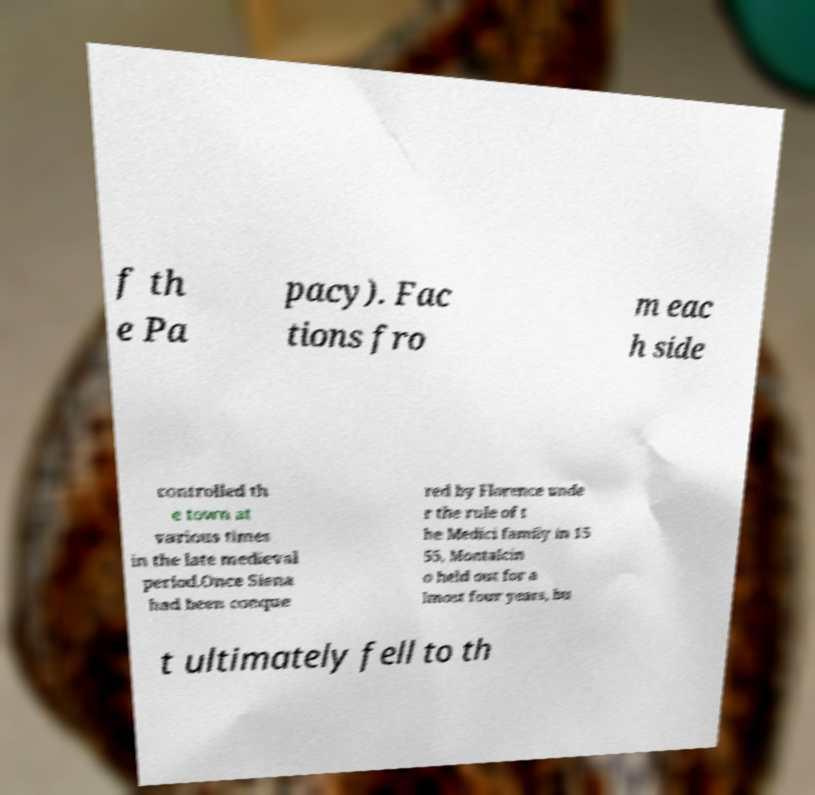Could you assist in decoding the text presented in this image and type it out clearly? f th e Pa pacy). Fac tions fro m eac h side controlled th e town at various times in the late medieval period.Once Siena had been conque red by Florence unde r the rule of t he Medici family in 15 55, Montalcin o held out for a lmost four years, bu t ultimately fell to th 